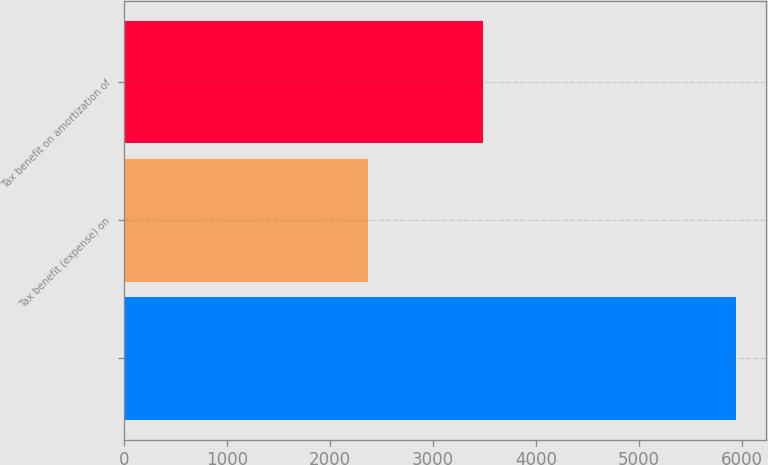Convert chart. <chart><loc_0><loc_0><loc_500><loc_500><bar_chart><ecel><fcel>Tax benefit (expense) on<fcel>Tax benefit on amortization of<nl><fcel>5936.8<fcel>2363<fcel>3482<nl></chart> 